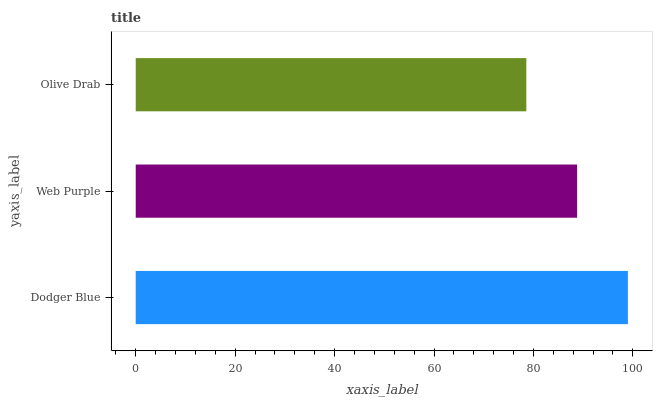Is Olive Drab the minimum?
Answer yes or no. Yes. Is Dodger Blue the maximum?
Answer yes or no. Yes. Is Web Purple the minimum?
Answer yes or no. No. Is Web Purple the maximum?
Answer yes or no. No. Is Dodger Blue greater than Web Purple?
Answer yes or no. Yes. Is Web Purple less than Dodger Blue?
Answer yes or no. Yes. Is Web Purple greater than Dodger Blue?
Answer yes or no. No. Is Dodger Blue less than Web Purple?
Answer yes or no. No. Is Web Purple the high median?
Answer yes or no. Yes. Is Web Purple the low median?
Answer yes or no. Yes. Is Olive Drab the high median?
Answer yes or no. No. Is Dodger Blue the low median?
Answer yes or no. No. 